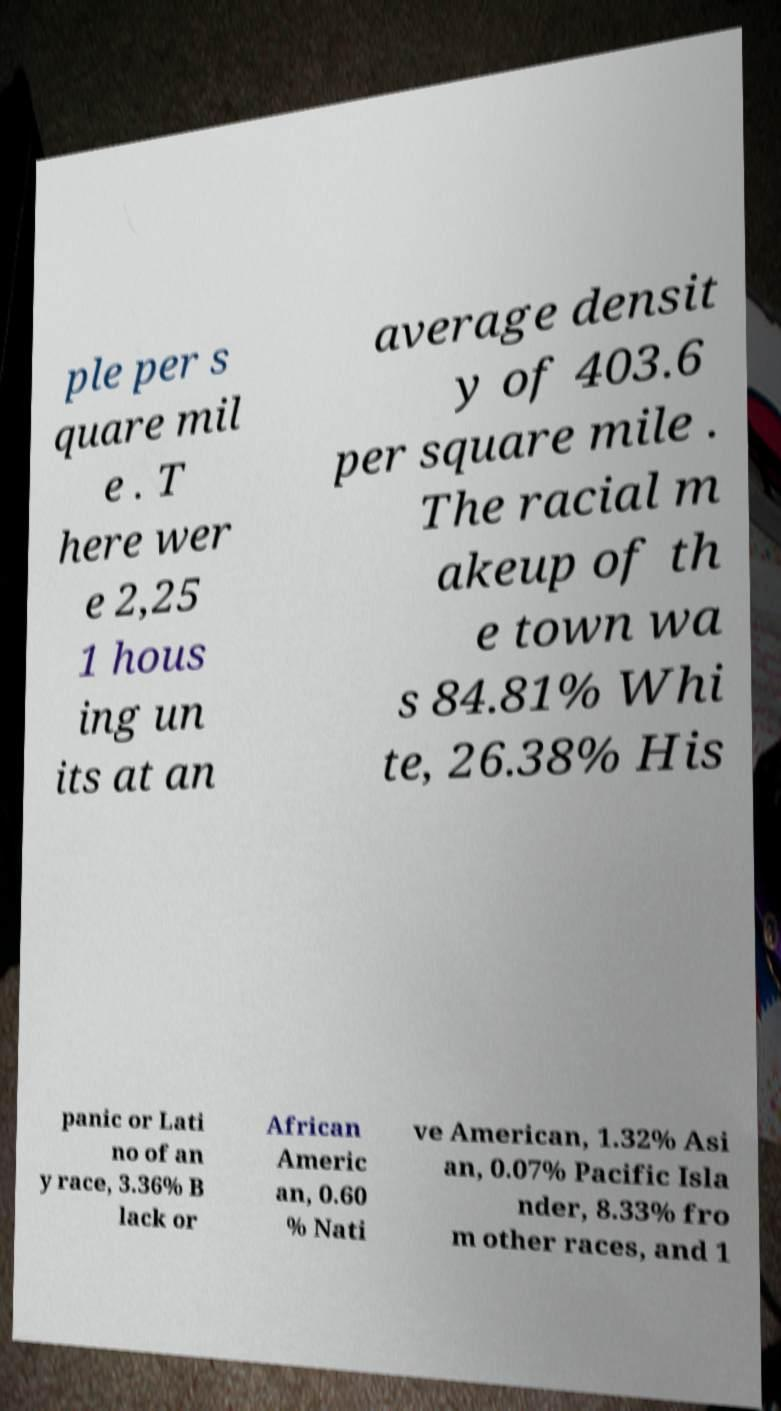Please read and relay the text visible in this image. What does it say? ple per s quare mil e . T here wer e 2,25 1 hous ing un its at an average densit y of 403.6 per square mile . The racial m akeup of th e town wa s 84.81% Whi te, 26.38% His panic or Lati no of an y race, 3.36% B lack or African Americ an, 0.60 % Nati ve American, 1.32% Asi an, 0.07% Pacific Isla nder, 8.33% fro m other races, and 1 